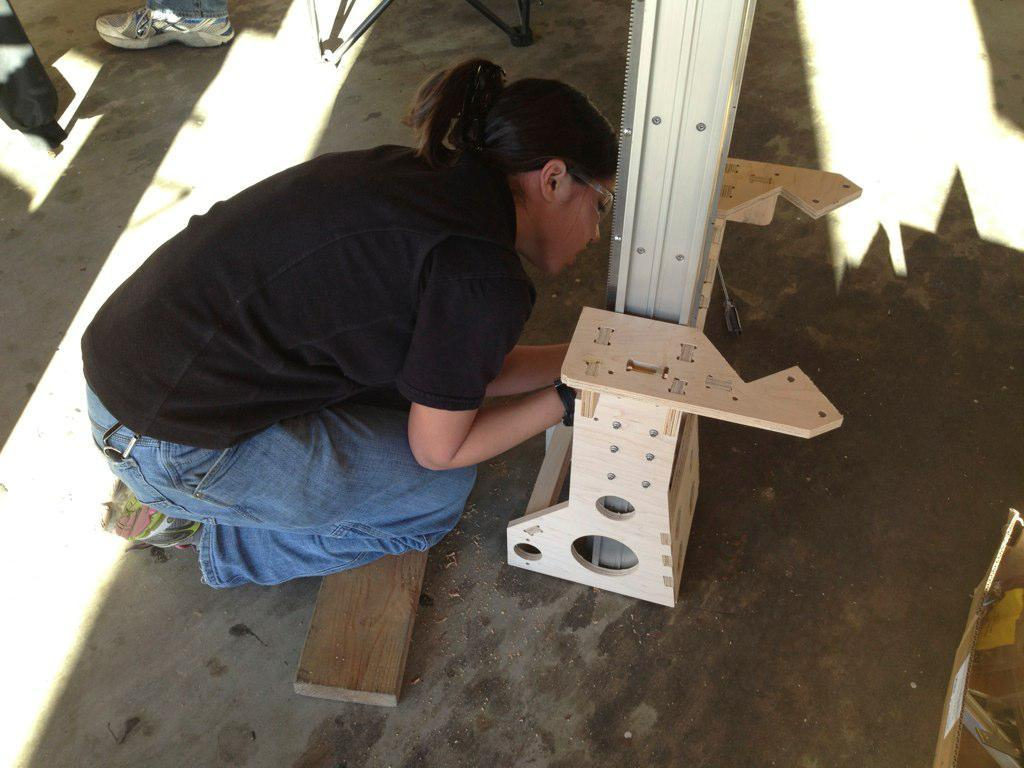What is the woman holding in the center of the image? There is a woman holding an object in the center of the image. What can be seen in the background of the image? There is a pole, a shoe, wooden objects, and a few other unspecified objects in the background of the image. What country is the woman from in the image? There is no information about the woman's country of origin in the image. Can you describe the woman's tongue in the image? There is no information about the woman's tongue in the image. 